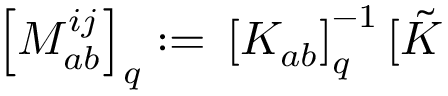Convert formula to latex. <formula><loc_0><loc_0><loc_500><loc_500>\left [ M _ { a b } ^ { i j } \right ] _ { q } \colon = \, \left [ K _ { a b } \right ] _ { q } ^ { - 1 } [ \tilde { K }</formula> 